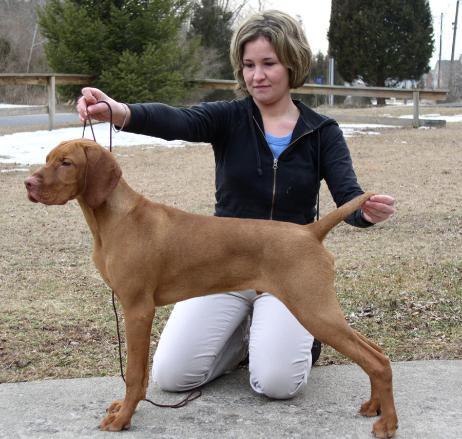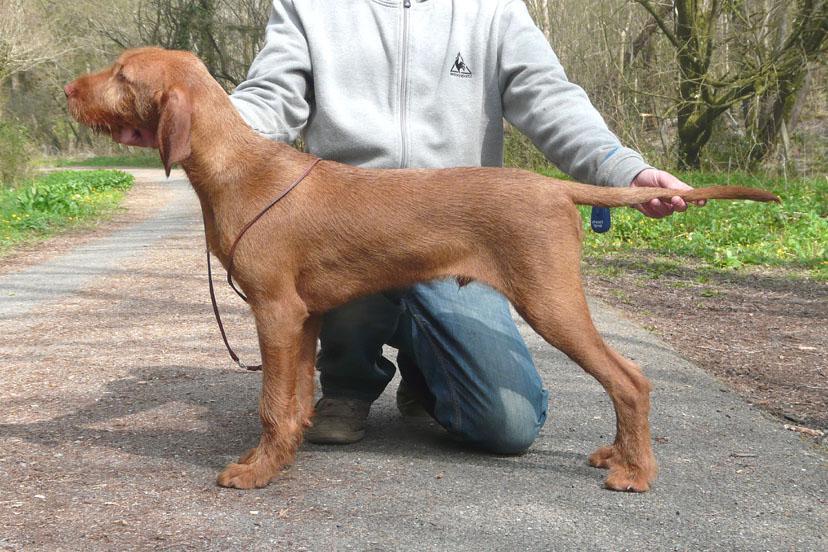The first image is the image on the left, the second image is the image on the right. For the images displayed, is the sentence "IN at least one image there is a collared dog sitting straight forward." factually correct? Answer yes or no. No. The first image is the image on the left, the second image is the image on the right. Evaluate the accuracy of this statement regarding the images: "The right image shows a person in blue jeans kneeling behind a leftward-facing dog standing in profile, with one hand on the dog's chin and the other hand on its tail.". Is it true? Answer yes or no. Yes. 